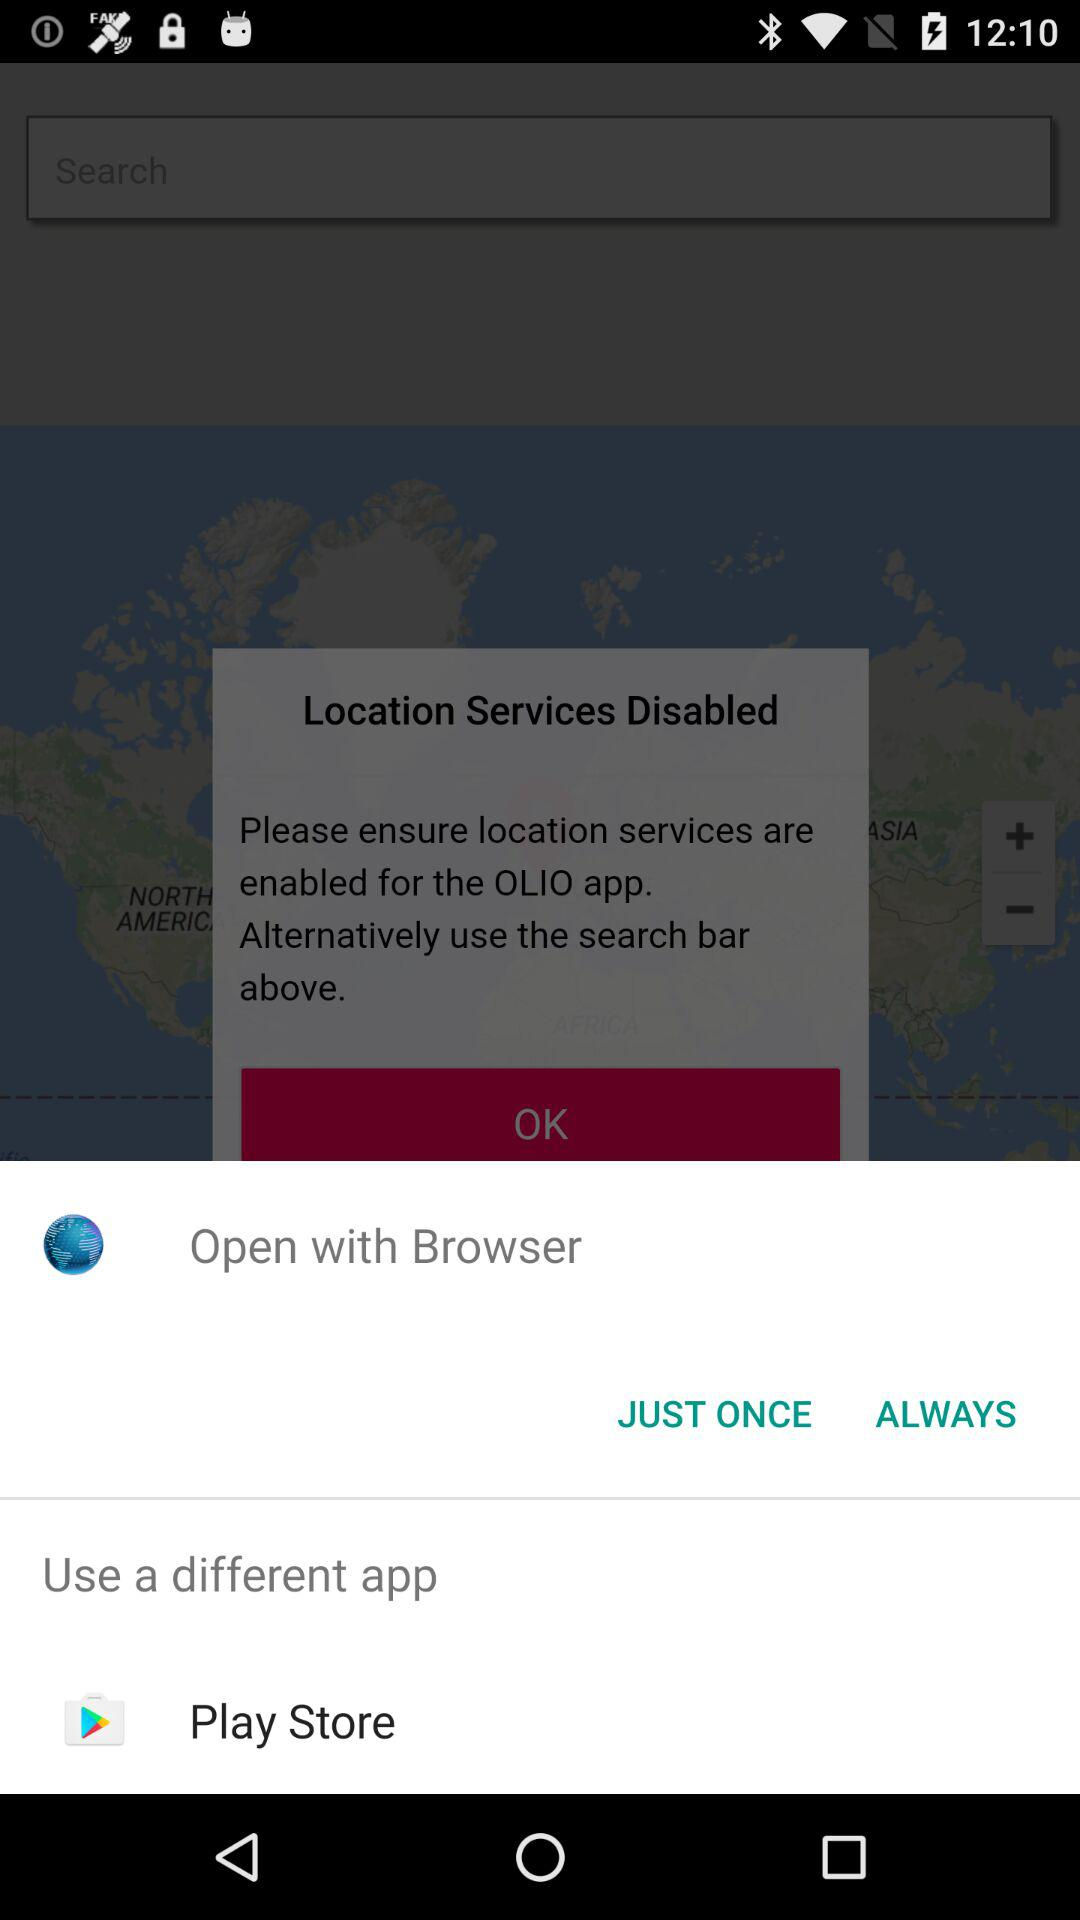What different applications can we use? The different application that we can use is "Play Store". 